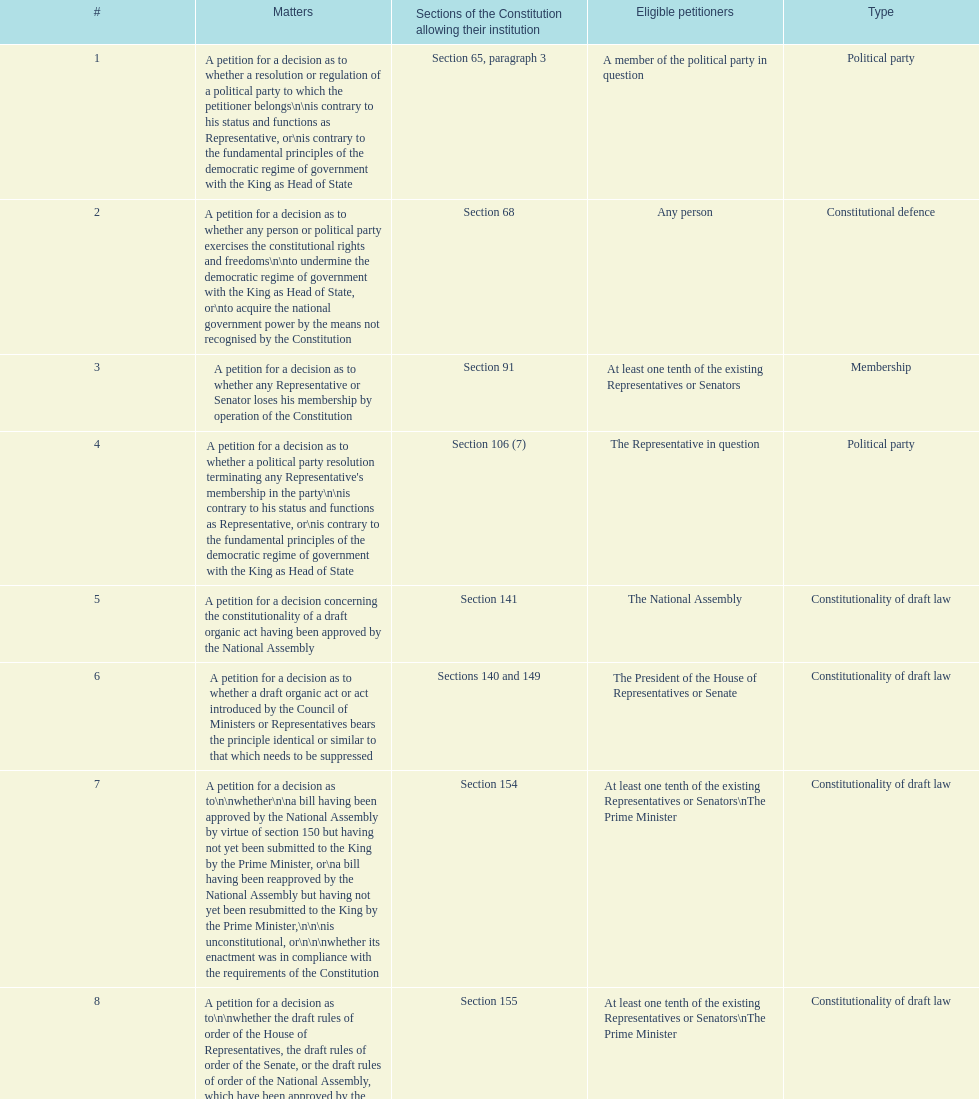What is the number of issues classified as "type" under the political party? 3. 